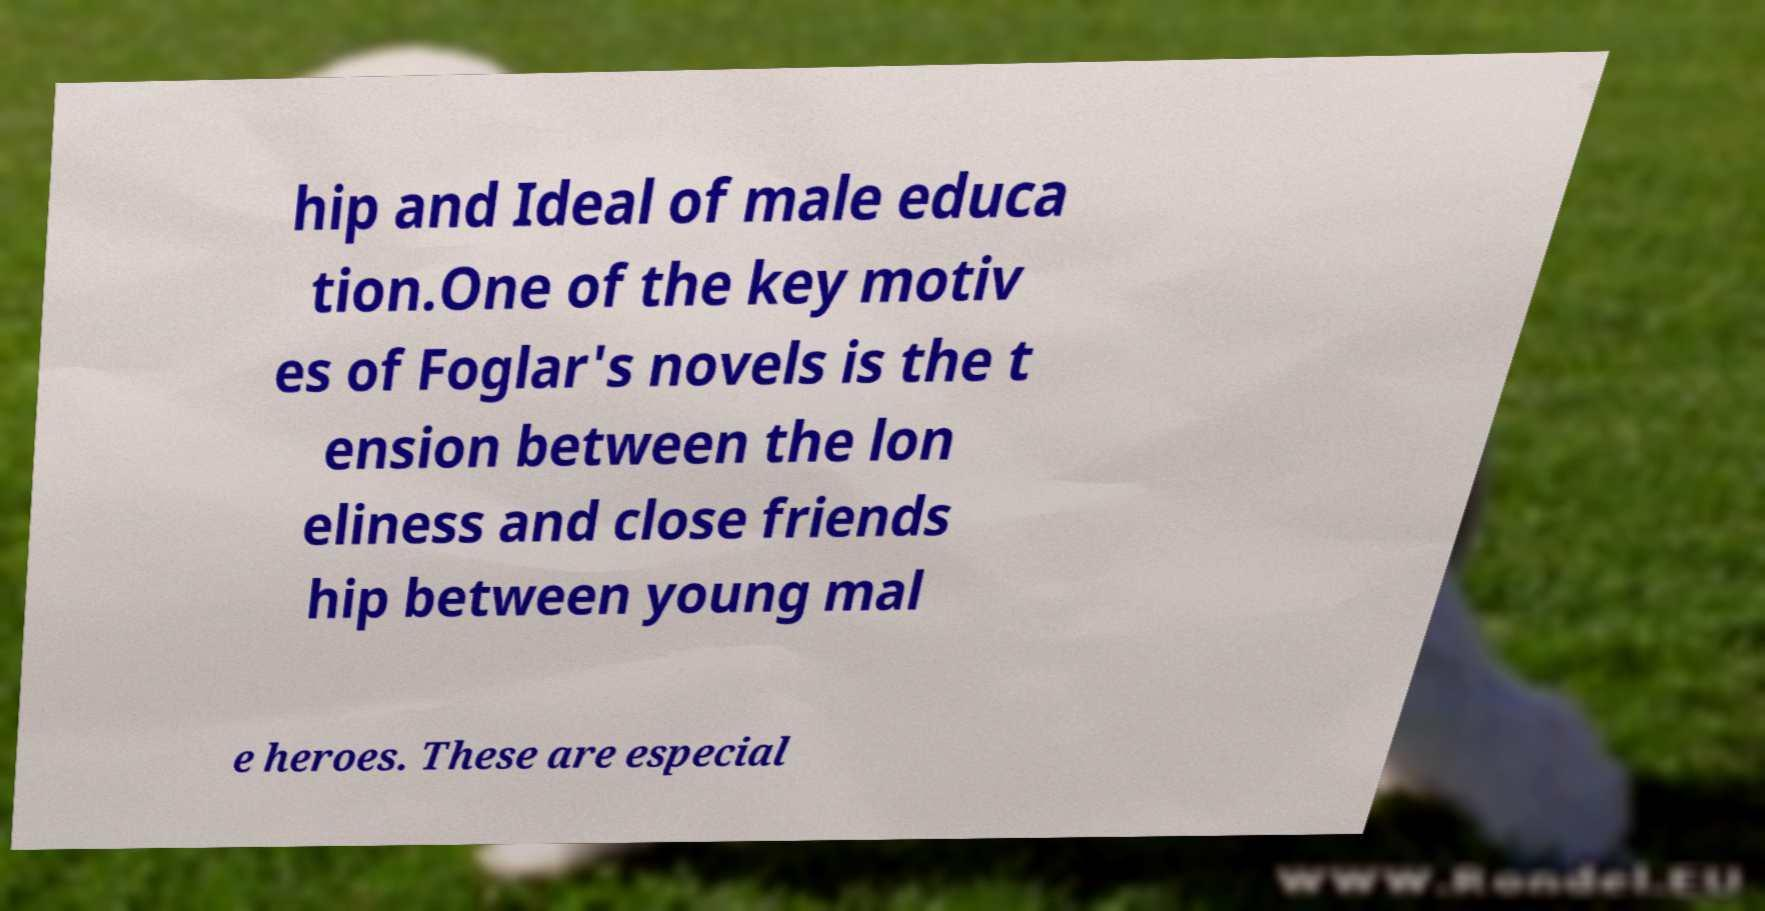For documentation purposes, I need the text within this image transcribed. Could you provide that? hip and Ideal of male educa tion.One of the key motiv es of Foglar's novels is the t ension between the lon eliness and close friends hip between young mal e heroes. These are especial 